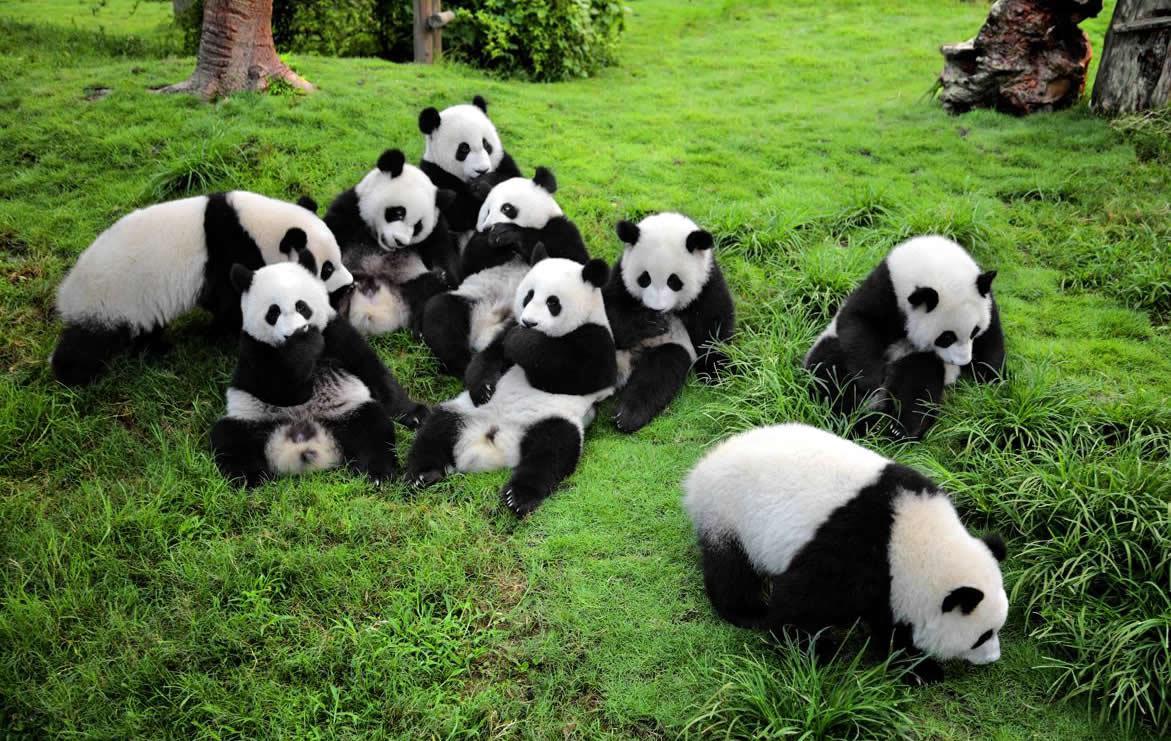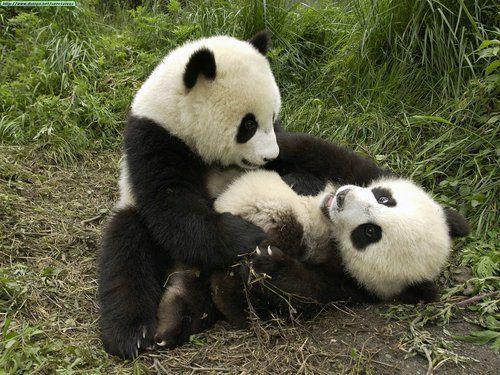The first image is the image on the left, the second image is the image on the right. For the images displayed, is the sentence "there are  exactly four pandas in one of the images" factually correct? Answer yes or no. No. The first image is the image on the left, the second image is the image on the right. Analyze the images presented: Is the assertion "An image shows two pandas who appear to be playfully wrestling." valid? Answer yes or no. Yes. 